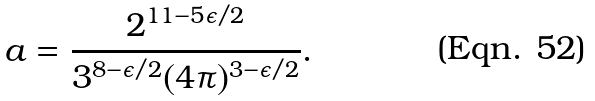Convert formula to latex. <formula><loc_0><loc_0><loc_500><loc_500>a = \frac { 2 ^ { 1 1 - 5 \epsilon / 2 } } { 3 ^ { 8 - \epsilon / 2 } ( 4 \pi ) ^ { 3 - \epsilon / 2 } } .</formula> 